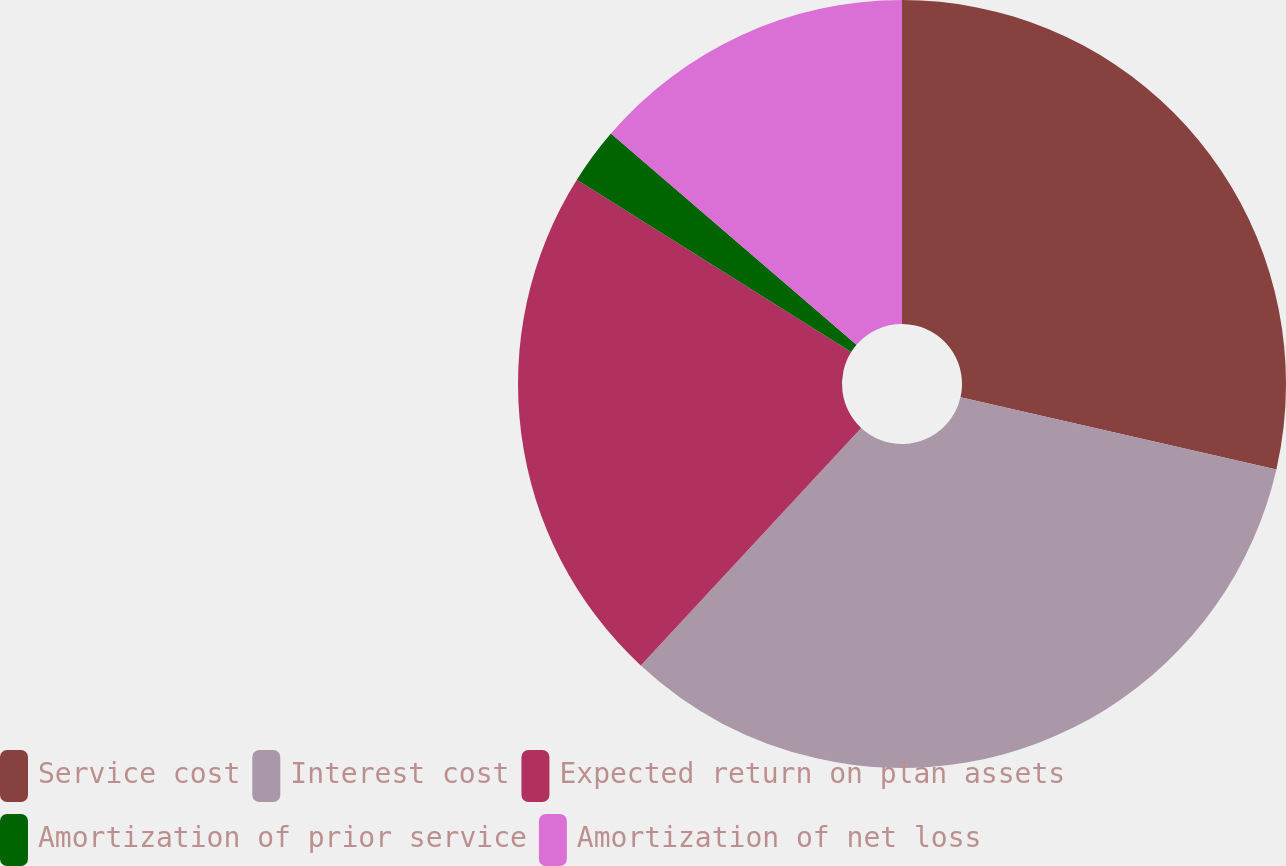<chart> <loc_0><loc_0><loc_500><loc_500><pie_chart><fcel>Service cost<fcel>Interest cost<fcel>Expected return on plan assets<fcel>Amortization of prior service<fcel>Amortization of net loss<nl><fcel>28.57%<fcel>33.33%<fcel>22.02%<fcel>2.38%<fcel>13.69%<nl></chart> 